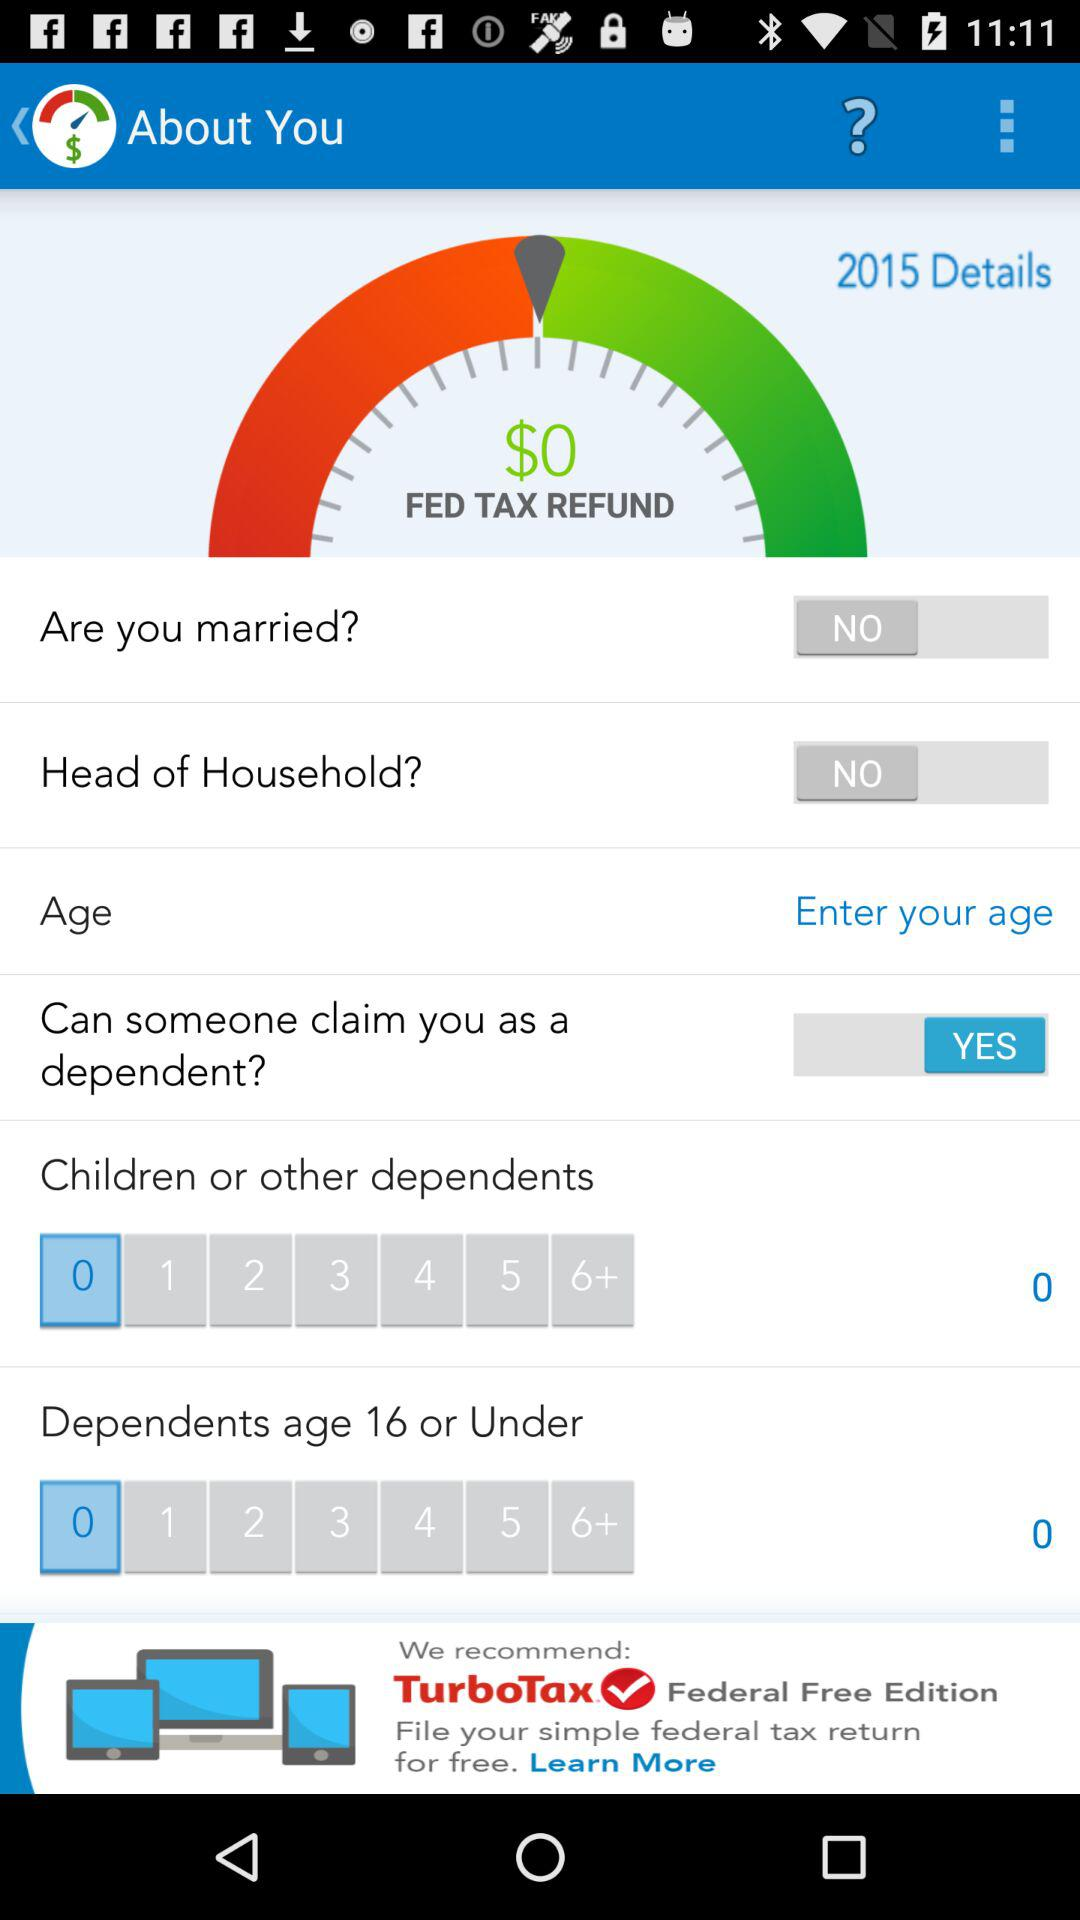Which year is given for details? The given year is 2015. 